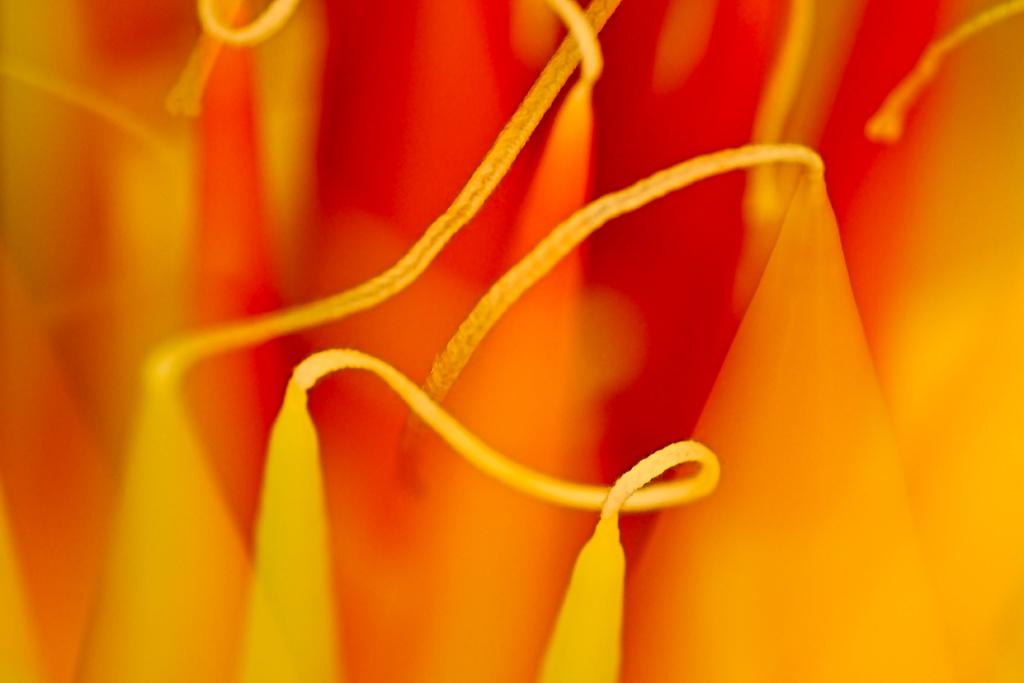What type of objects can be seen in the image? There are candles in the image. What colors are the candles? The candles are in yellow and orange colors. Can you describe any other details visible in the image? There are visible threads in the image. What type of lettuce can be seen growing in the image? There is no lettuce present in the image; it features candles in yellow and orange colors with visible threads. 